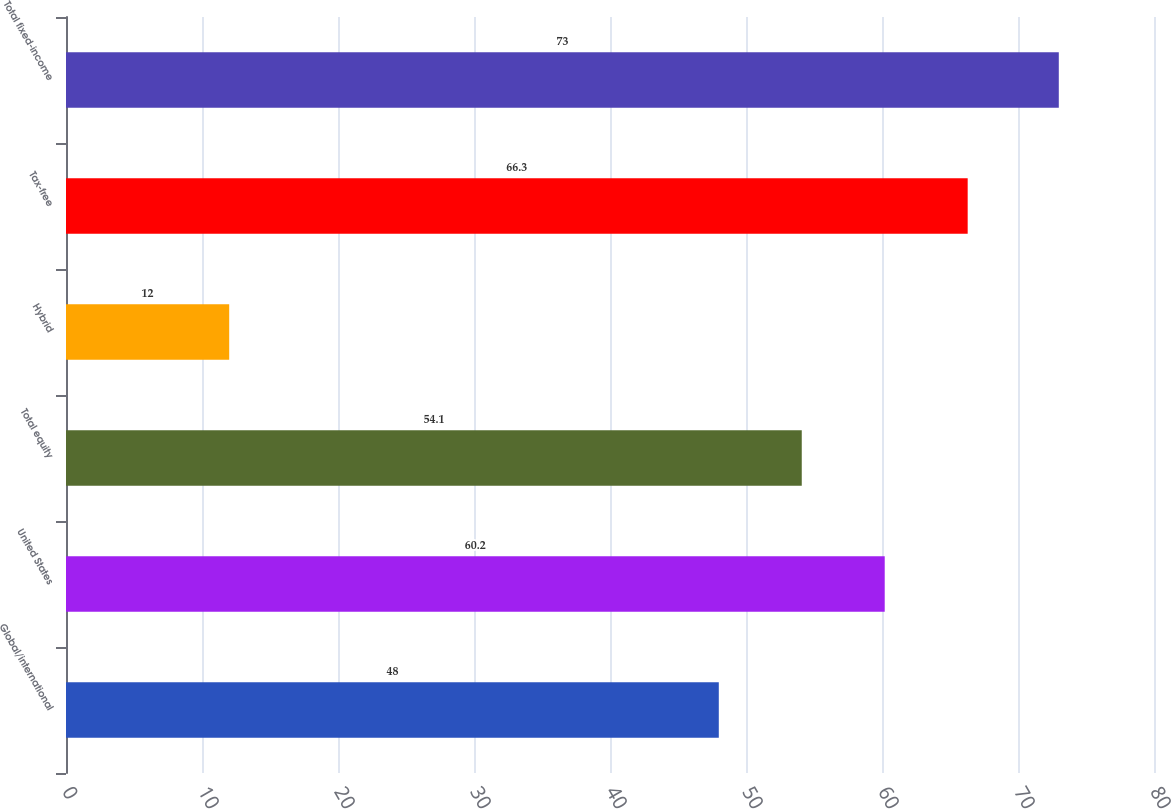Convert chart to OTSL. <chart><loc_0><loc_0><loc_500><loc_500><bar_chart><fcel>Global/international<fcel>United States<fcel>Total equity<fcel>Hybrid<fcel>Tax-free<fcel>Total fixed-income<nl><fcel>48<fcel>60.2<fcel>54.1<fcel>12<fcel>66.3<fcel>73<nl></chart> 